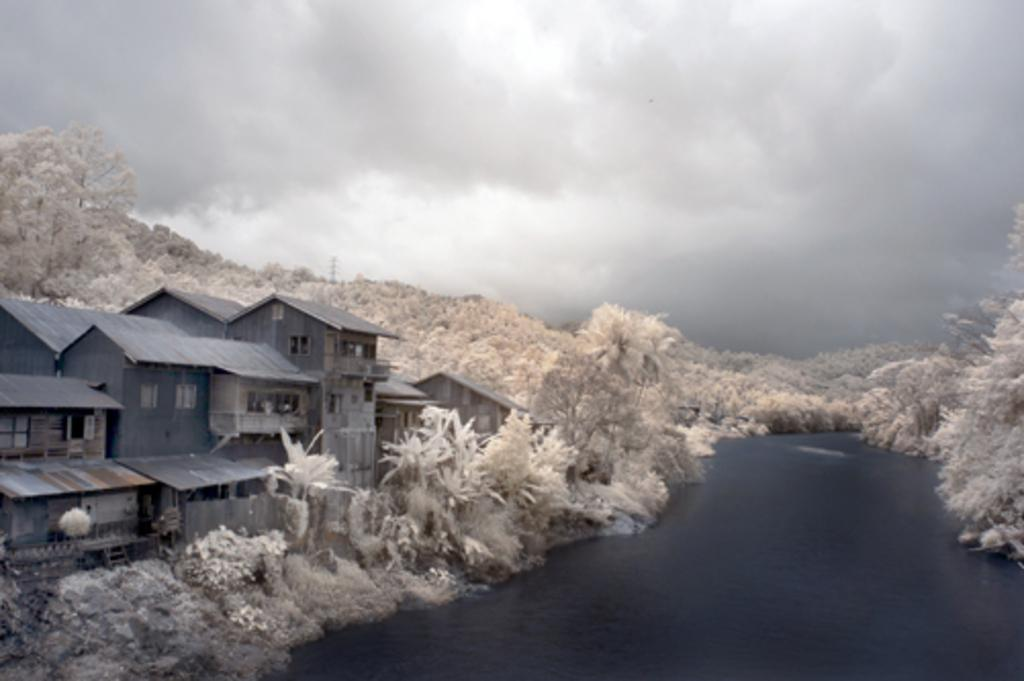What is the main structure in the middle of the image? There is a building in the middle of the image. What else can be seen in the middle of the image besides the building? There are trees in the middle of the image. What is at the bottom of the image? There is water at the bottom of the image. What is visible at the top of the image? There is sky at the top of the image. Can you tell me how many zebras are standing on the tray in the image? There is no tray or zebras present in the image. What color is the leaf on the tree in the image? There is no leaf mentioned in the provided facts, and the image does not show any leaves in detail. 